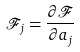<formula> <loc_0><loc_0><loc_500><loc_500>\mathcal { F } _ { j } = \frac { \partial \mathcal { F } } { \partial a _ { j } }</formula> 